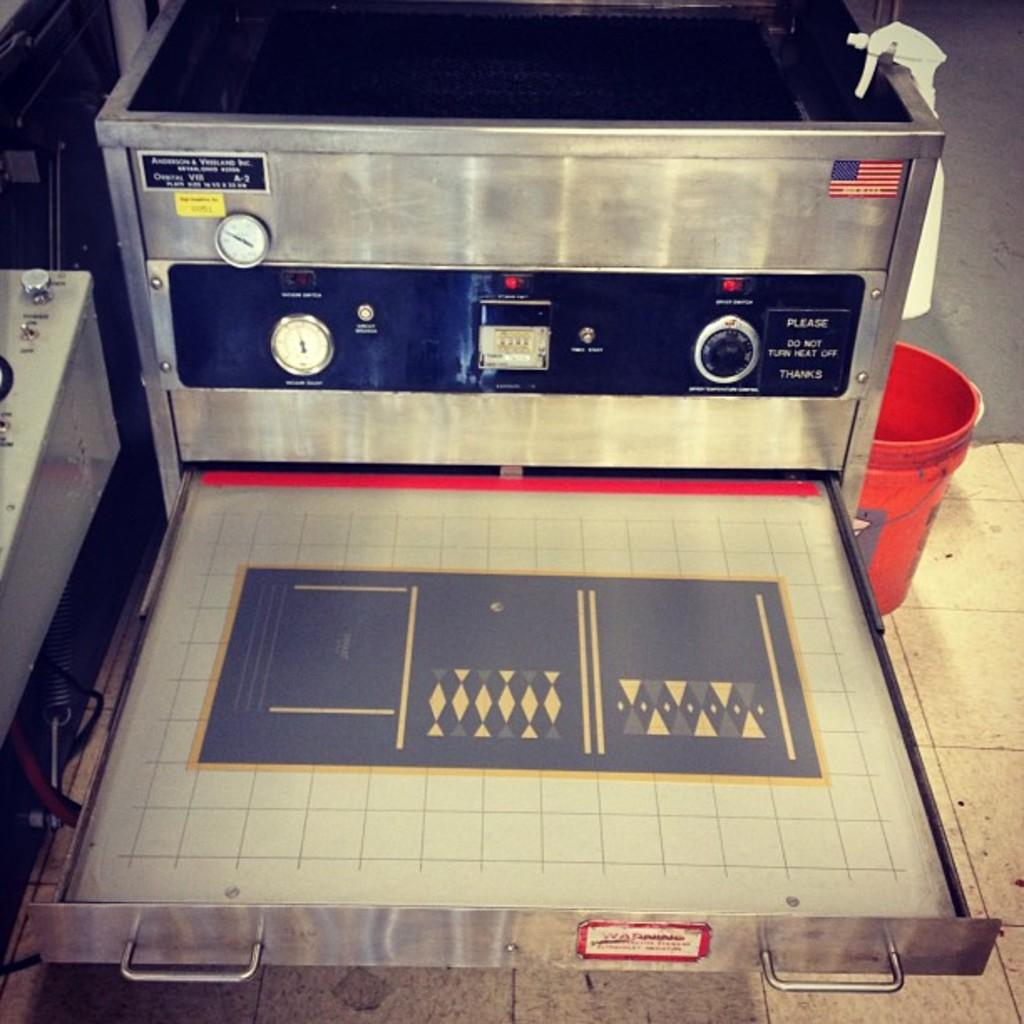<image>
Create a compact narrative representing the image presented. A gray device with a graph recorder and the words Please do not turn heat off  Thanks sign on the side below the American flag sticker 